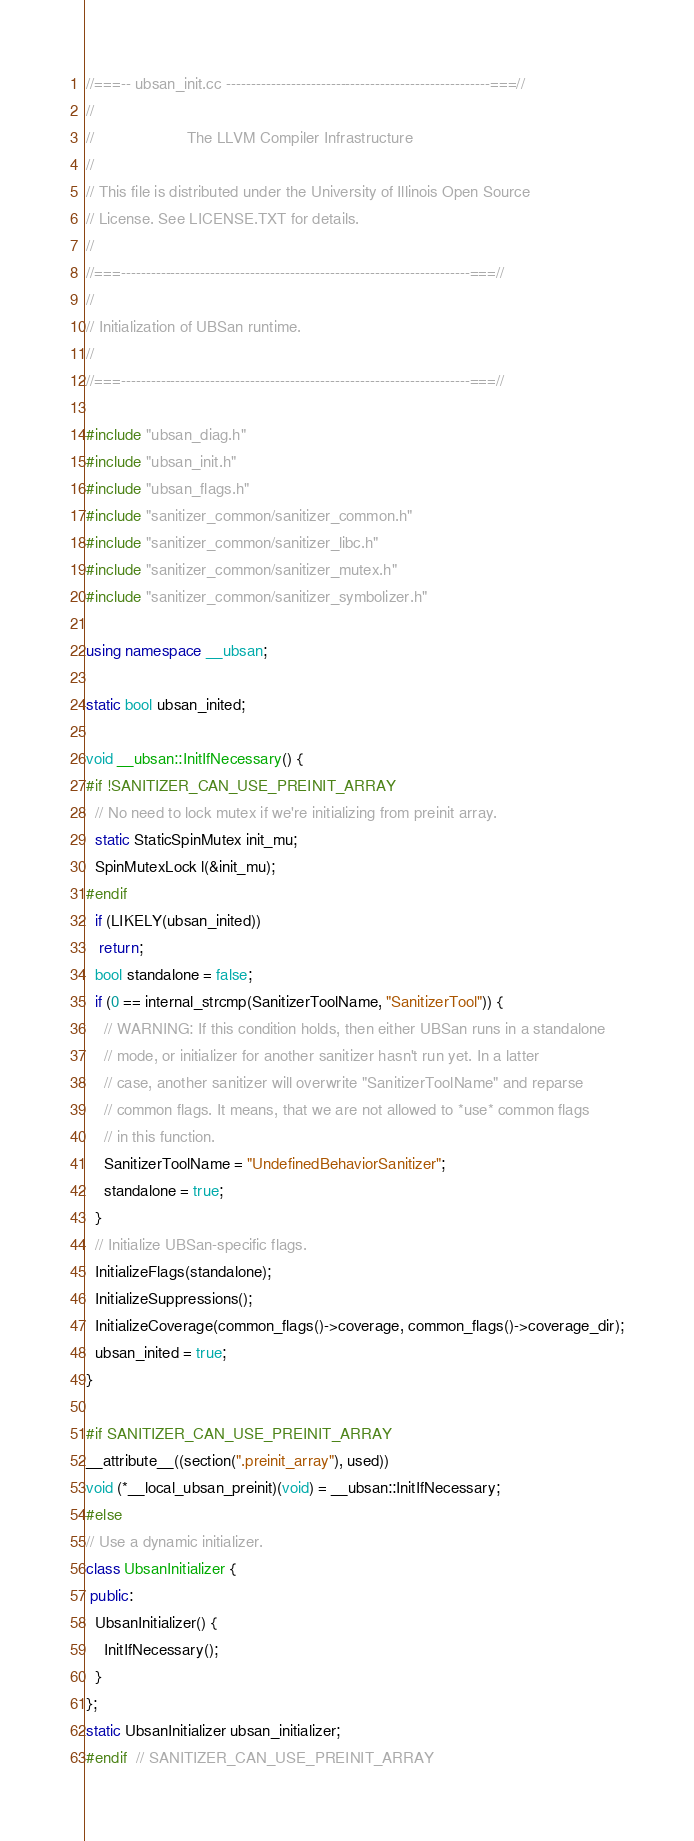Convert code to text. <code><loc_0><loc_0><loc_500><loc_500><_C++_>//===-- ubsan_init.cc -----------------------------------------------------===//
//
//                     The LLVM Compiler Infrastructure
//
// This file is distributed under the University of Illinois Open Source
// License. See LICENSE.TXT for details.
//
//===----------------------------------------------------------------------===//
//
// Initialization of UBSan runtime.
//
//===----------------------------------------------------------------------===//

#include "ubsan_diag.h"
#include "ubsan_init.h"
#include "ubsan_flags.h"
#include "sanitizer_common/sanitizer_common.h"
#include "sanitizer_common/sanitizer_libc.h"
#include "sanitizer_common/sanitizer_mutex.h"
#include "sanitizer_common/sanitizer_symbolizer.h"

using namespace __ubsan;

static bool ubsan_inited;

void __ubsan::InitIfNecessary() {
#if !SANITIZER_CAN_USE_PREINIT_ARRAY
  // No need to lock mutex if we're initializing from preinit array.
  static StaticSpinMutex init_mu;
  SpinMutexLock l(&init_mu);
#endif
  if (LIKELY(ubsan_inited))
   return;
  bool standalone = false;
  if (0 == internal_strcmp(SanitizerToolName, "SanitizerTool")) {
    // WARNING: If this condition holds, then either UBSan runs in a standalone
    // mode, or initializer for another sanitizer hasn't run yet. In a latter
    // case, another sanitizer will overwrite "SanitizerToolName" and reparse
    // common flags. It means, that we are not allowed to *use* common flags
    // in this function.
    SanitizerToolName = "UndefinedBehaviorSanitizer";
    standalone = true;
  }
  // Initialize UBSan-specific flags.
  InitializeFlags(standalone);
  InitializeSuppressions();
  InitializeCoverage(common_flags()->coverage, common_flags()->coverage_dir);
  ubsan_inited = true;
}

#if SANITIZER_CAN_USE_PREINIT_ARRAY
__attribute__((section(".preinit_array"), used))
void (*__local_ubsan_preinit)(void) = __ubsan::InitIfNecessary;
#else
// Use a dynamic initializer.
class UbsanInitializer {
 public:
  UbsanInitializer() {
    InitIfNecessary();
  }
};
static UbsanInitializer ubsan_initializer;
#endif  // SANITIZER_CAN_USE_PREINIT_ARRAY
</code> 